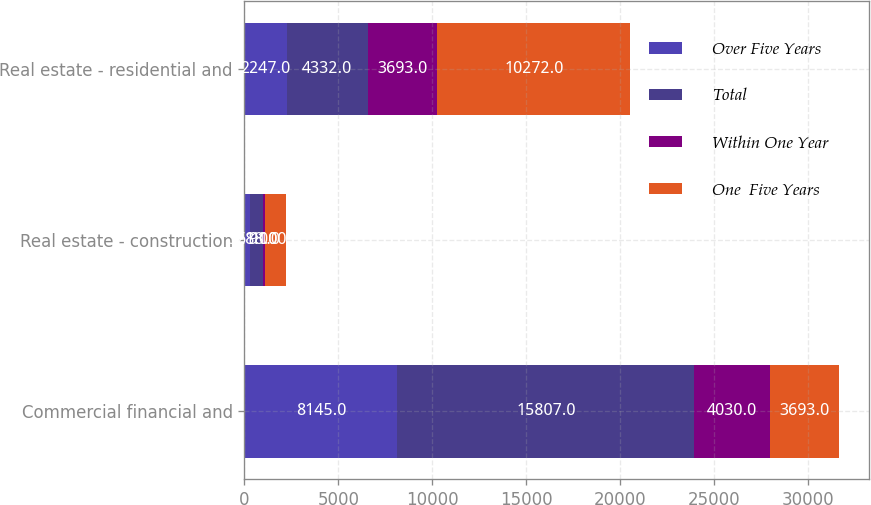Convert chart. <chart><loc_0><loc_0><loc_500><loc_500><stacked_bar_chart><ecel><fcel>Commercial financial and<fcel>Real estate - construction<fcel>Real estate - residential and<nl><fcel>Over Five Years<fcel>8145<fcel>321<fcel>2247<nl><fcel>Total<fcel>15807<fcel>688<fcel>4332<nl><fcel>Within One Year<fcel>4030<fcel>91<fcel>3693<nl><fcel>One  Five Years<fcel>3693<fcel>1100<fcel>10272<nl></chart> 